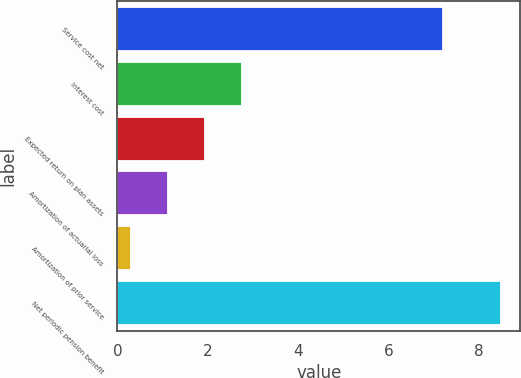<chart> <loc_0><loc_0><loc_500><loc_500><bar_chart><fcel>Service cost net<fcel>Interest cost<fcel>Expected return on plan assets<fcel>Amortization of actuarial loss<fcel>Amortization of prior service<fcel>Net periodic pension benefit<nl><fcel>7.2<fcel>2.76<fcel>1.94<fcel>1.12<fcel>0.3<fcel>8.5<nl></chart> 